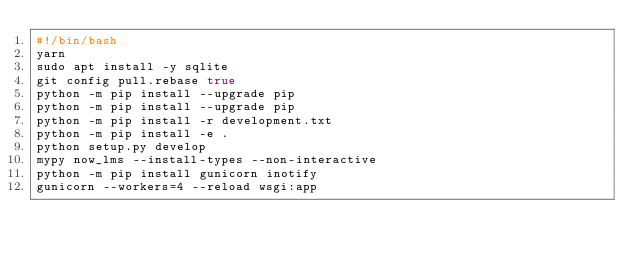<code> <loc_0><loc_0><loc_500><loc_500><_Bash_>#!/bin/bash
yarn
sudo apt install -y sqlite
git config pull.rebase true
python -m pip install --upgrade pip
python -m pip install --upgrade pip
python -m pip install -r development.txt
python -m pip install -e .
python setup.py develop
mypy now_lms --install-types --non-interactive 
python -m pip install gunicorn inotify
gunicorn --workers=4 --reload wsgi:app</code> 